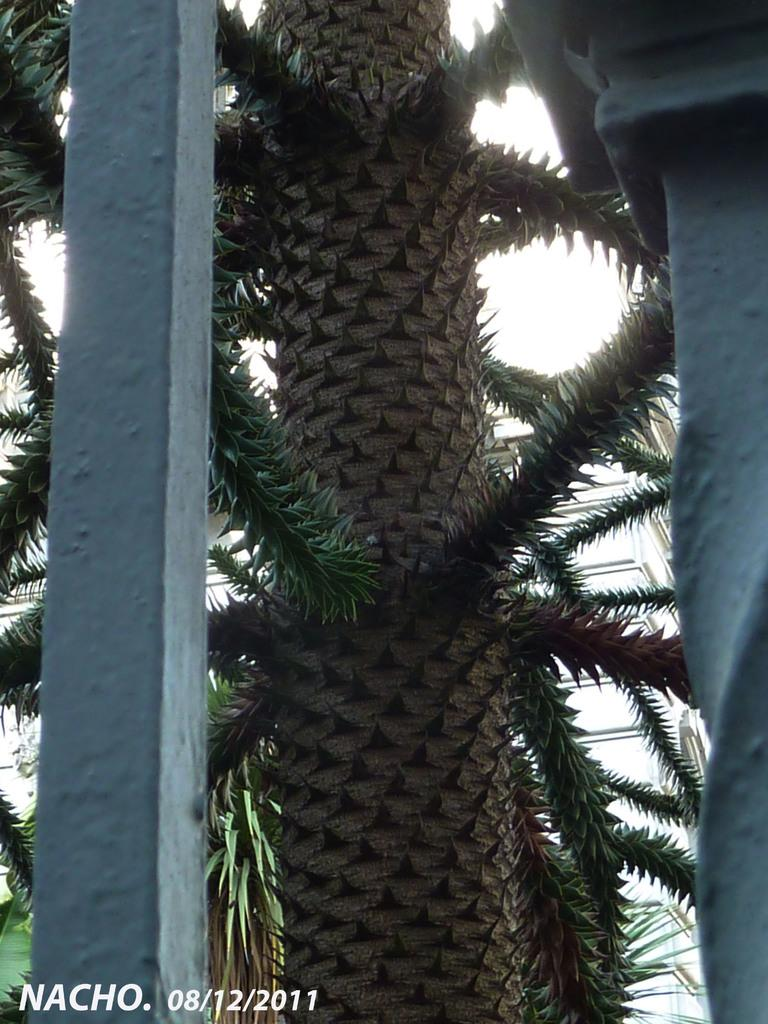What is the main subject of the image? The main subject of the image is a tree trunk. Can you describe the tree in the image? The tree has branches. What other objects can be seen in the image? There are iron poles visible in the image. What can be seen in the background of the image? There is a building visible in the background of the image. How many pieces of pie can be seen on the tree branches in the image? There are no pieces of pie present in the image; it features a tree trunk with branches. What type of nose is visible on the tree trunk in the image? There is no nose present on the tree trunk in the image. 